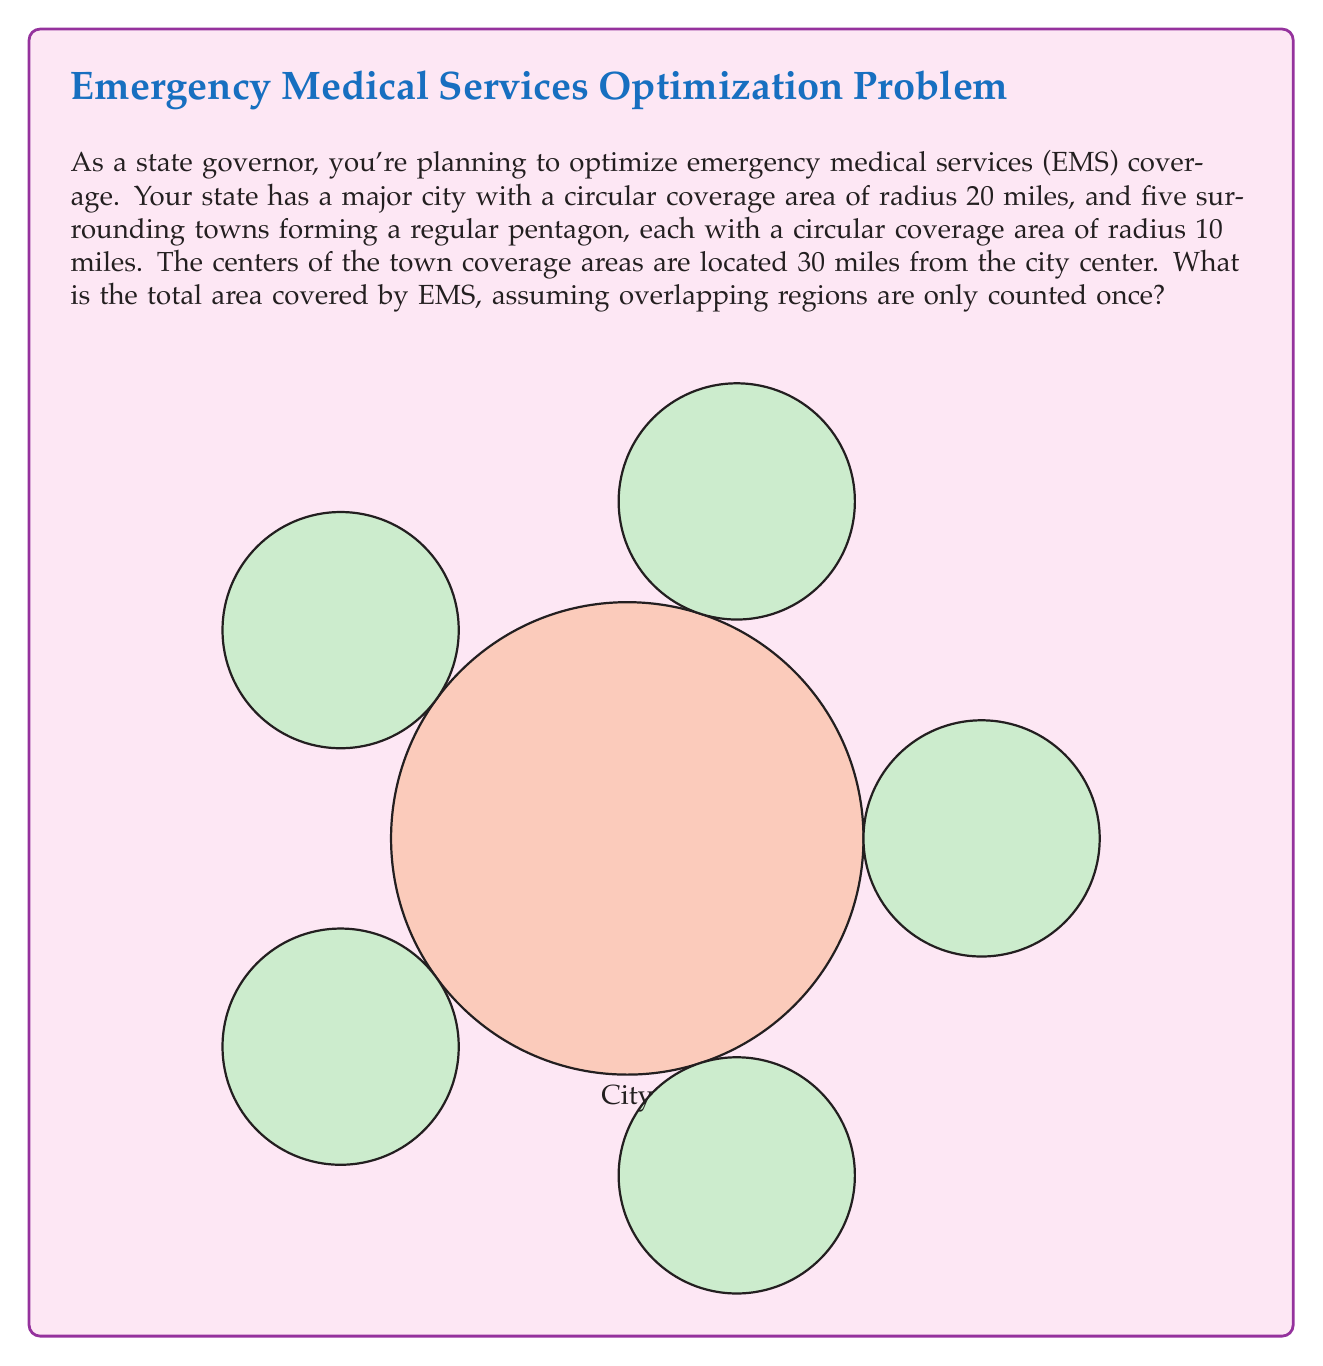Give your solution to this math problem. Let's approach this step-by-step:

1) Area of the central city:
   $$A_c = \pi r^2 = \pi (20)^2 = 400\pi \text{ sq miles}$$

2) Area of each town:
   $$A_t = \pi r^2 = \pi (10)^2 = 100\pi \text{ sq miles}$$

3) Total area of all five towns:
   $$A_{\text{towns}} = 5 \times 100\pi = 500\pi \text{ sq miles}$$

4) However, we can't simply add these areas because there may be overlaps. We need to calculate the area of the regular pentagon formed by the town centers:
   
   Side length of the pentagon: $s = 2 \times 30 \times \sin(36°) \approx 35.3553$ miles
   
   Area of the pentagon: $$A_p = \frac{1}{4}\sqrt{(25+10\sqrt{5})}s^2 \approx 2895.9 \text{ sq miles}$$

5) Now, we have the area of a shape that encompasses all our circles. We can subtract the areas not covered:
   
   Uncovered area in each corner of the pentagon:
   $$A_{\text{corner}} = \frac{1}{5}A_p - (\frac{1}{4}\pi r^2) \approx 579.18 - 78.54 = 500.64 \text{ sq miles}$$
   
   Total uncovered area: $5 \times 500.64 = 2503.2 \text{ sq miles}$

6) Therefore, the total covered area is:
   $$A_{\text{total}} = A_p - 2503.2 \approx 392.7 \text{ sq miles}$$

7) Adding this to the central city area:
   $$A_{\text{EMS}} = 400\pi + 392.7 \approx 1649.3 \text{ sq miles}$$
Answer: The total area covered by EMS is approximately 1649.3 square miles. 